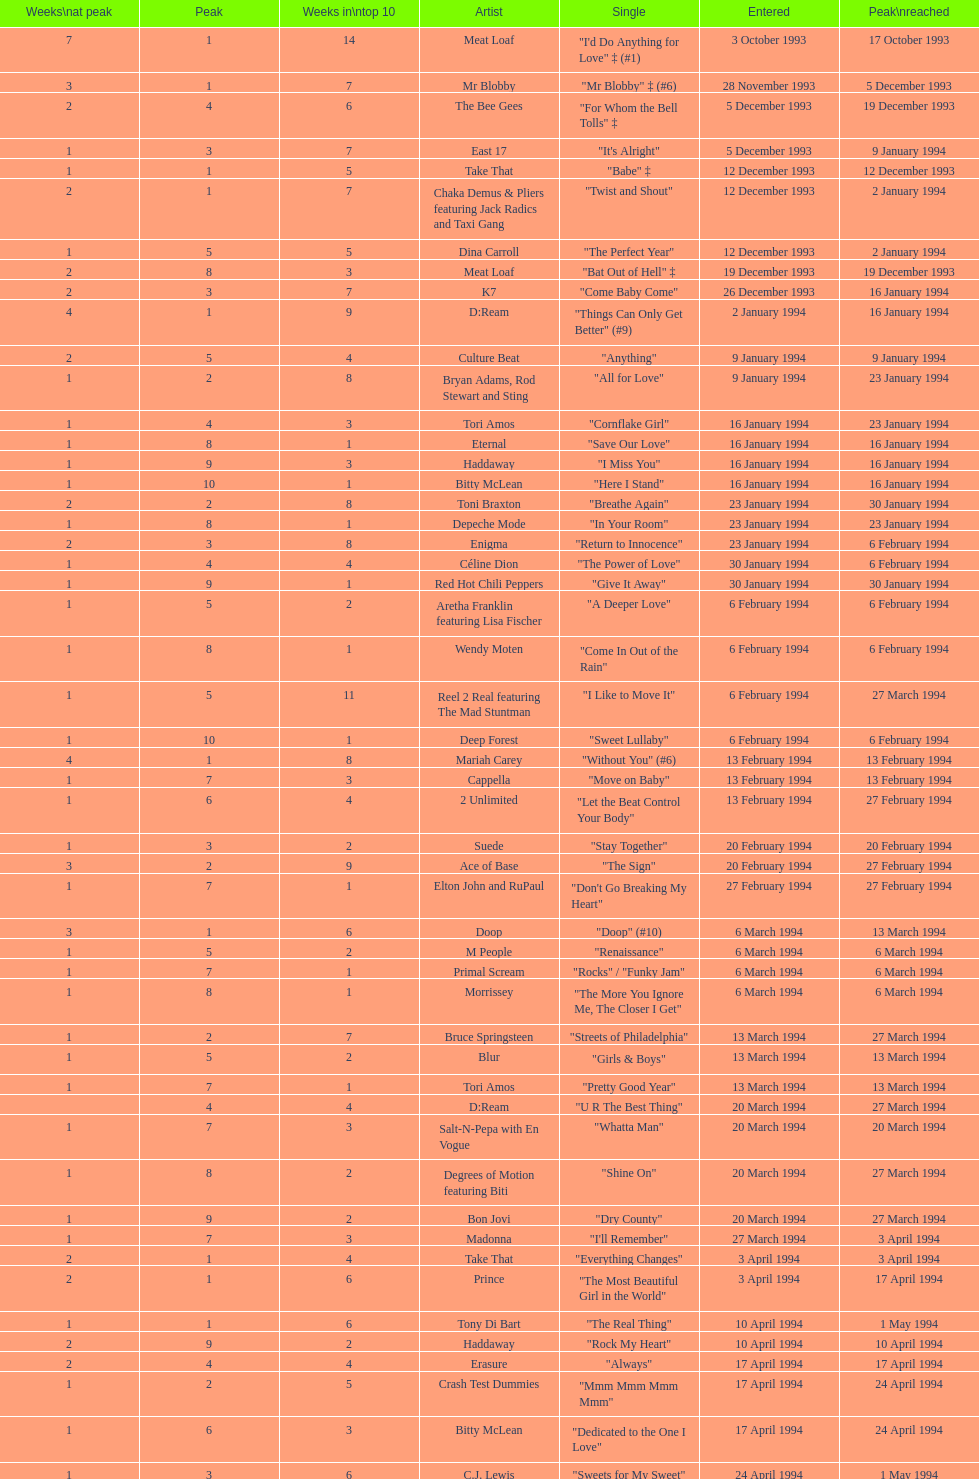Which artist came on the list after oasis? Tinman. Could you help me parse every detail presented in this table? {'header': ['Weeks\\nat peak', 'Peak', 'Weeks in\\ntop 10', 'Artist', 'Single', 'Entered', 'Peak\\nreached'], 'rows': [['7', '1', '14', 'Meat Loaf', '"I\'d Do Anything for Love" ‡ (#1)', '3 October 1993', '17 October 1993'], ['3', '1', '7', 'Mr Blobby', '"Mr Blobby" ‡ (#6)', '28 November 1993', '5 December 1993'], ['2', '4', '6', 'The Bee Gees', '"For Whom the Bell Tolls" ‡', '5 December 1993', '19 December 1993'], ['1', '3', '7', 'East 17', '"It\'s Alright"', '5 December 1993', '9 January 1994'], ['1', '1', '5', 'Take That', '"Babe" ‡', '12 December 1993', '12 December 1993'], ['2', '1', '7', 'Chaka Demus & Pliers featuring Jack Radics and Taxi Gang', '"Twist and Shout"', '12 December 1993', '2 January 1994'], ['1', '5', '5', 'Dina Carroll', '"The Perfect Year"', '12 December 1993', '2 January 1994'], ['2', '8', '3', 'Meat Loaf', '"Bat Out of Hell" ‡', '19 December 1993', '19 December 1993'], ['2', '3', '7', 'K7', '"Come Baby Come"', '26 December 1993', '16 January 1994'], ['4', '1', '9', 'D:Ream', '"Things Can Only Get Better" (#9)', '2 January 1994', '16 January 1994'], ['2', '5', '4', 'Culture Beat', '"Anything"', '9 January 1994', '9 January 1994'], ['1', '2', '8', 'Bryan Adams, Rod Stewart and Sting', '"All for Love"', '9 January 1994', '23 January 1994'], ['1', '4', '3', 'Tori Amos', '"Cornflake Girl"', '16 January 1994', '23 January 1994'], ['1', '8', '1', 'Eternal', '"Save Our Love"', '16 January 1994', '16 January 1994'], ['1', '9', '3', 'Haddaway', '"I Miss You"', '16 January 1994', '16 January 1994'], ['1', '10', '1', 'Bitty McLean', '"Here I Stand"', '16 January 1994', '16 January 1994'], ['2', '2', '8', 'Toni Braxton', '"Breathe Again"', '23 January 1994', '30 January 1994'], ['1', '8', '1', 'Depeche Mode', '"In Your Room"', '23 January 1994', '23 January 1994'], ['2', '3', '8', 'Enigma', '"Return to Innocence"', '23 January 1994', '6 February 1994'], ['1', '4', '4', 'Céline Dion', '"The Power of Love"', '30 January 1994', '6 February 1994'], ['1', '9', '1', 'Red Hot Chili Peppers', '"Give It Away"', '30 January 1994', '30 January 1994'], ['1', '5', '2', 'Aretha Franklin featuring Lisa Fischer', '"A Deeper Love"', '6 February 1994', '6 February 1994'], ['1', '8', '1', 'Wendy Moten', '"Come In Out of the Rain"', '6 February 1994', '6 February 1994'], ['1', '5', '11', 'Reel 2 Real featuring The Mad Stuntman', '"I Like to Move It"', '6 February 1994', '27 March 1994'], ['1', '10', '1', 'Deep Forest', '"Sweet Lullaby"', '6 February 1994', '6 February 1994'], ['4', '1', '8', 'Mariah Carey', '"Without You" (#6)', '13 February 1994', '13 February 1994'], ['1', '7', '3', 'Cappella', '"Move on Baby"', '13 February 1994', '13 February 1994'], ['1', '6', '4', '2 Unlimited', '"Let the Beat Control Your Body"', '13 February 1994', '27 February 1994'], ['1', '3', '2', 'Suede', '"Stay Together"', '20 February 1994', '20 February 1994'], ['3', '2', '9', 'Ace of Base', '"The Sign"', '20 February 1994', '27 February 1994'], ['1', '7', '1', 'Elton John and RuPaul', '"Don\'t Go Breaking My Heart"', '27 February 1994', '27 February 1994'], ['3', '1', '6', 'Doop', '"Doop" (#10)', '6 March 1994', '13 March 1994'], ['1', '5', '2', 'M People', '"Renaissance"', '6 March 1994', '6 March 1994'], ['1', '7', '1', 'Primal Scream', '"Rocks" / "Funky Jam"', '6 March 1994', '6 March 1994'], ['1', '8', '1', 'Morrissey', '"The More You Ignore Me, The Closer I Get"', '6 March 1994', '6 March 1994'], ['1', '2', '7', 'Bruce Springsteen', '"Streets of Philadelphia"', '13 March 1994', '27 March 1994'], ['1', '5', '2', 'Blur', '"Girls & Boys"', '13 March 1994', '13 March 1994'], ['1', '7', '1', 'Tori Amos', '"Pretty Good Year"', '13 March 1994', '13 March 1994'], ['', '4', '4', 'D:Ream', '"U R The Best Thing"', '20 March 1994', '27 March 1994'], ['1', '7', '3', 'Salt-N-Pepa with En Vogue', '"Whatta Man"', '20 March 1994', '20 March 1994'], ['1', '8', '2', 'Degrees of Motion featuring Biti', '"Shine On"', '20 March 1994', '27 March 1994'], ['1', '9', '2', 'Bon Jovi', '"Dry County"', '20 March 1994', '27 March 1994'], ['1', '7', '3', 'Madonna', '"I\'ll Remember"', '27 March 1994', '3 April 1994'], ['2', '1', '4', 'Take That', '"Everything Changes"', '3 April 1994', '3 April 1994'], ['2', '1', '6', 'Prince', '"The Most Beautiful Girl in the World"', '3 April 1994', '17 April 1994'], ['1', '1', '6', 'Tony Di Bart', '"The Real Thing"', '10 April 1994', '1 May 1994'], ['2', '9', '2', 'Haddaway', '"Rock My Heart"', '10 April 1994', '10 April 1994'], ['2', '4', '4', 'Erasure', '"Always"', '17 April 1994', '17 April 1994'], ['1', '2', '5', 'Crash Test Dummies', '"Mmm Mmm Mmm Mmm"', '17 April 1994', '24 April 1994'], ['1', '6', '3', 'Bitty McLean', '"Dedicated to the One I Love"', '17 April 1994', '24 April 1994'], ['1', '3', '6', 'C.J. Lewis', '"Sweets for My Sweet"', '24 April 1994', '1 May 1994'], ['1', '10', '1', 'The Pretenders', '"I\'ll Stand by You"', '24 April 1994', '24 April 1994'], ['1', '1', '6', 'Stiltskin', '"Inside"', '1 May 1994', '8 May 1994'], ['1', '7', '2', 'Clubhouse featuring Carl', '"Light My Fire"', '1 May 1994', '1 May 1994'], ['2', '1', '7', 'Manchester United Football Squad featuring Status Quo', '"Come on You Reds"', '1 May 1994', '15 May 1994'], ['2', '3', '5', 'East 17', '"Around the World"', '8 May 1994', '15 May 1994'], ['1', '8', '3', 'Eternal', '"Just a Step from Heaven"', '8 May 1994', '15 May 1994'], ['15', '1', '20', 'Wet Wet Wet', '"Love Is All Around" (#1)', '15 May 1994', '29 May 1994'], ['1', '6', '3', '2 Unlimited', '"The Real Thing"', '15 May 1994', '22 May 1994'], ['1', '8', '2', 'Bad Boys Inc', '"More to This World"', '15 May 1994', '22 May 1994'], ['2', '4', '5', 'Maxx', '"Get-A-Way"', '22 May 1994', '29 May 1994'], ['1', '4', '6', 'The Prodigy', '"No Good (Start the Dance)"', '22 May 1994', '12 June 1994'], ['3', '2', '7', 'Big Mountain', '"Baby, I Love Your Way"', '29 May 1994', '5 June 1994'], ['1', '9', '1', 'Gloworm', '"Carry Me Home"', '29 May 1994', '29 May 1994'], ['1', '6', '3', 'Absolutely Fabulous', '"Absolutely Fabulous"', '5 June 1994', '12 June 1994'], ['2', '3', '5', 'Dawn Penn', '"You Don\'t Love Me (No, No, No)"', '5 June 1994', '12 June 1994'], ['1', '10', '1', 'Guns N Roses', '"Since I Don\'t Have You"', '5 June 1994', '5 June 1994'], ['1', '5', '3', 'Ace of Base', '"Don\'t Turn Around"', '12 June 1994', '19 June 1994'], ['1', '3', '8', 'The Grid', '"Swamp Thing"', '12 June 1994', '26 June 1994'], ['1', '8', '2', 'Mariah Carey', '"Anytime You Need a Friend"', '12 June 1994', '19 June 1994'], ['7', '2', '12', 'All-4-One', '"I Swear" (#5)', '19 June 1994', '26 June 1994'], ['2', '7', '2', 'Reel 2 Real featuring The Mad Stuntman', '"Go On Move"', '26 June 1994', '26 June 1994'], ['1', '5', '6', 'Aswad', '"Shine"', '26 June 1994', '17 July 1994'], ['1', '10', '1', 'Cappella', '"U & Me"', '26 June 1994', '26 June 1994'], ['2', '3', '3', 'Take That', '"Love Ain\'t Here Anymore"', '3 July 1994', '3 July 1994'], ['3', '3', '7', 'The B.C. 52s', '"(Meet) The Flintstones"', '3 July 1994', '17 July 1994'], ['1', '8', '2', 'GUN', '"Word Up!"', '3 July 1994', '3 July 1994'], ['1', '7', '2', '2 Cowboys', '"Everybody Gonfi-Gon"', '10 July 1994', '10 July 1994'], ['2', '2', '9', 'Let Loose', '"Crazy for You" (#8)', '10 July 1994', '14 August 1994'], ['1', '5', '8', 'Warren G and Nate Dogg', '"Regulate"', '17 July 1994', '24 July 1994'], ['2', '10', '2', 'C.J. Lewis', '"Everything is Alright (Uptight)"', '17 July 1994', '17 July 1994'], ['1', '6', '1', 'Erasure', '"Run to the Sun"', '24 July 1994', '24 July 1994'], ['2', '4', '7', 'China Black', '"Searching"', '24 July 1994', '7 August 1994'], ['1', '1', '4', 'PJ & Duncan', '"Let\'s Get Ready to Rhumble"', '31 July 1994', '31 March 2013'], ['1', '8', '2', 'Maxx', '"No More (I Can\'t Stand It)"', '31 July 1994', '7 August 1994'], ['1', '2', '6', 'Red Dragon with Brian and Tony Gold', '"Compliments on Your Kiss"', '7 August 1994', '28 August 1994'], ['1', '6', '4', 'DJ Miko', '"What\'s Up?"', '7 August 1994', '14 August 1994'], ['1', '3', '6', "Youssou N'Dour featuring Neneh Cherry", '"7 Seconds"', '14 August 1994', '4 September 1994'], ['2', '10', '2', 'Oasis', '"Live Forever"', '14 August 1994', '14 August 1994'], ['1', '9', '1', 'Tinman', '"Eighteen Strings"', '21 August 1994', '21 August 1994'], ['1', '5', '5', 'Boyz II Men', '"I\'ll Make Love to You"', '28 August 1994', '4 September 1994'], ['1', '10', '1', 'Blur', '"Parklife"', '28 August 1994', '28 August 1994'], ['1', '2', '3', 'Kylie Minogue', '"Confide in Me"', '4 September 1994', '4 September 1994'], ['2', '2', '6', 'Corona', '"The Rhythm of the Night"', '4 September 1994', '18 September 1994'], ['4', '1', '10', 'Whigfield', '"Saturday Night" (#2)', '11 September 1994', '11 September 1994'], ['2', '3', '4', 'Luther Vandross and Mariah Carey', '"Endless Love"', '11 September 1994', '11 September 1994'], ['1', '9', '2', 'R.E.M.', '"What\'s the Frequency, Kenneth"', '11 September 1994', '11 September 1994'], ['1', '8', '3', 'M-Beat featuring General Levy', '"Incredible"', '11 September 1994', '18 September 1994'], ['3', '2', '11', 'Bon Jovi', '"Always" (#7)', '18 September 1994', '2 October 1994'], ['1', '4', '6', 'Cyndi Lauper', '"Hey Now (Girls Just Want to Have Fun)"', '25 September 1994', '2 October 1994'], ['1', '6', '6', 'Lisa Loeb and Nine Stories', '"Stay (I Missed You)"', '25 September 1994', '25 September 1994'], ['2', '7', '3', 'East 17', '"Steam"', '25 September 1994', '25 September 1994'], ['1', '5', '2', 'Madonna', '"Secret"', '2 October 1994', '2 October 1994'], ['4', '1', '10', 'Pato Banton featuring Ali and Robin Campbell', '"Baby Come Back" (#4)', '2 October 1994', '23 October 1994'], ['1', '4', '6', 'Michelle Gayle', '"Sweetness"', '2 October 1994', '30 October 1994'], ['2', '1', '3', 'Take That', '"Sure"', '9 October 1994', '9 October 1994'], ['1', '7', '1', 'Oasis', '"Cigarettes & Alcohol"', '16 October 1994', '16 October 1994'], ['1', '6', '4', 'Snap! featuring Summer', '"Welcome to Tomorrow (Are You Ready?)"', '16 October 1994', '30 October 1994'], ['1', '3', '5', 'R. Kelly', '"She\'s Got That Vibe"', '16 October 1994', '6 November 1994'], ['1', '9', '1', 'Sting', '"When We Dance"', '23 October 1994', '23 October 1994'], ['1', '4', '4', 'Eternal', '"Oh Baby I..."', '30 October 1994', '6 November 1994'], ['1', '9', '2', 'Ultimate Kaos', '"Some Girls"', '30 October 1994', '30 October 1994'], ['1', '2', '5', 'MC Sar and Real McCoy', '"Another Night"', '6 November 1994', '13 November 1994'], ['1', '4', '4', 'Sheryl Crow', '"All I Wanna Do"', '6 November 1994', '20 November 1994'], ['2', '1', '5', 'Baby D', '"Let Me Be Your Fantasy"', '13 November 1994', '20 November 1994'], ['1', '6', '3', 'M People', '"Sight for Sore Eyes"', '13 November 1994', '20 November 1994'], ['1', '9', '1', 'New Order', '"True Faith \'94"', '13 November 1994', '13 November 1994'], ['1', '3', '6', 'Louis Armstrong', '"We Have All the Time in the World"', '20 November 1994', '27 November 1994'], ['1', '4', '7', 'Jimmy Nail', '"Crocodile Shoes"', '20 November 1994', '4 December 1994'], ['1', '10', '1', 'Pearl Jam', '"Spin the Black Circle"', '20 November 1994', '20 November 1994'], ['1', '2', '2', 'The Stone Roses', '"Love Spreads"', '27 November 1994', '27 November 1994'], ['5', '1', '8', 'East 17', '"Stay Another Day" (#3)', '27 November 1994', '4 December 1994'], ['3', '2', '5', 'Mariah Carey', '"All I Want for Christmas Is You"', '4 December 1994', '11 December 1994'], ['1', '3', '3', 'The Mighty RAW', '"Power Rangers: The Official Single"', '11 December 1994', '11 December'], ['7', '1', '17', 'Celine Dion', '"Think Twice" ♦', '4 December 1994', '29 January 1995'], ['1', '2', '8', 'Boyzone', '"Love Me for a Reason" ♦', '4 December 1994', '1 January 1995'], ['1', '7', '2', 'Bon Jovi', '"Please Come Home for Christmas"', '11 December 1994', '11 December 1994'], ['1', '7', '2', 'Whigfield', '"Another Day" ♦', '11 December 1994', '1 January 1995'], ['3', '1', '10', 'Rednex', '"Cotton Eye Joe" ♦', '18 December 1994', '8 January 1995'], ['1', '5', '4', 'Zig and Zag', '"Them Girls, Them Girls" ♦', '18 December 1994', '1 January 1995'], ['1', '3', '4', 'Oasis', '"Whatever"', '25 December 1994', '25 December 1994']]} 